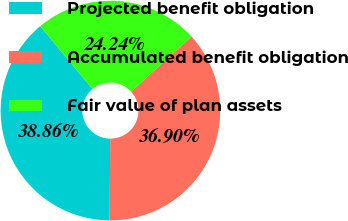<chart> <loc_0><loc_0><loc_500><loc_500><pie_chart><fcel>Projected benefit obligation<fcel>Accumulated benefit obligation<fcel>Fair value of plan assets<nl><fcel>38.86%<fcel>36.9%<fcel>24.24%<nl></chart> 